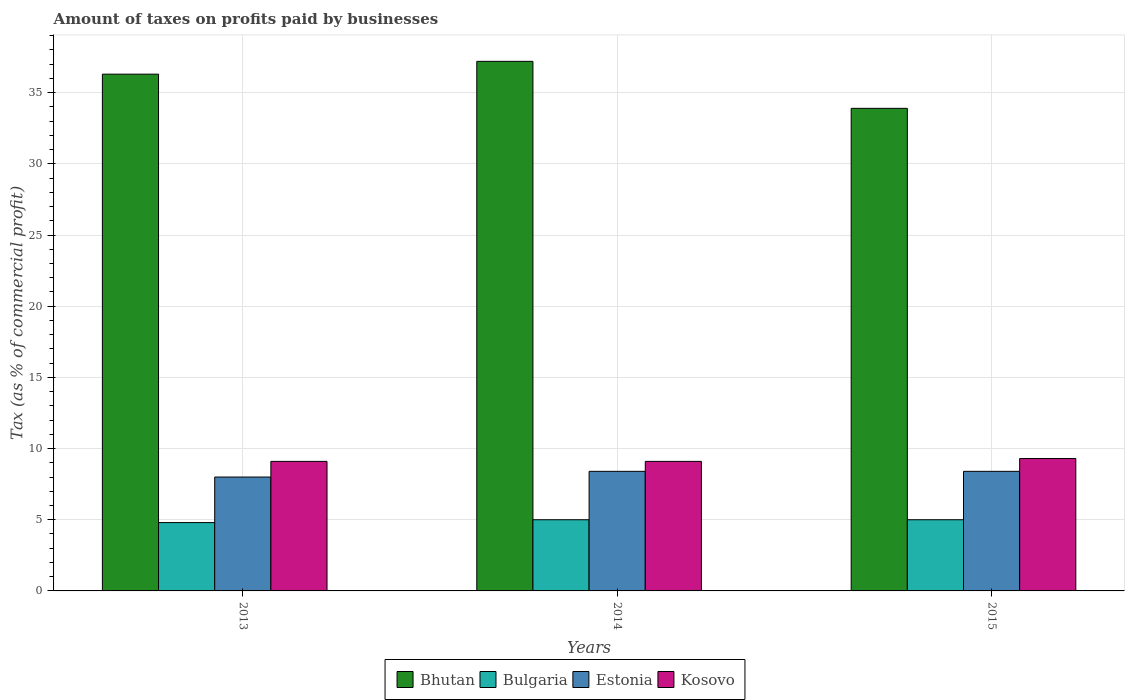How many different coloured bars are there?
Your answer should be very brief. 4. How many groups of bars are there?
Your answer should be compact. 3. Are the number of bars per tick equal to the number of legend labels?
Make the answer very short. Yes. Are the number of bars on each tick of the X-axis equal?
Provide a short and direct response. Yes. How many bars are there on the 1st tick from the left?
Offer a terse response. 4. In how many cases, is the number of bars for a given year not equal to the number of legend labels?
Your answer should be very brief. 0. Across all years, what is the maximum percentage of taxes paid by businesses in Estonia?
Offer a very short reply. 8.4. Across all years, what is the minimum percentage of taxes paid by businesses in Bulgaria?
Keep it short and to the point. 4.8. In which year was the percentage of taxes paid by businesses in Estonia minimum?
Offer a terse response. 2013. What is the total percentage of taxes paid by businesses in Estonia in the graph?
Offer a terse response. 24.8. What is the difference between the percentage of taxes paid by businesses in Bhutan in 2013 and that in 2015?
Make the answer very short. 2.4. What is the difference between the percentage of taxes paid by businesses in Estonia in 2015 and the percentage of taxes paid by businesses in Bhutan in 2013?
Provide a short and direct response. -27.9. What is the average percentage of taxes paid by businesses in Bhutan per year?
Make the answer very short. 35.8. In the year 2013, what is the difference between the percentage of taxes paid by businesses in Kosovo and percentage of taxes paid by businesses in Estonia?
Your answer should be compact. 1.1. In how many years, is the percentage of taxes paid by businesses in Bulgaria greater than 27 %?
Provide a short and direct response. 0. What is the ratio of the percentage of taxes paid by businesses in Bulgaria in 2014 to that in 2015?
Your answer should be compact. 1. Is the difference between the percentage of taxes paid by businesses in Kosovo in 2013 and 2014 greater than the difference between the percentage of taxes paid by businesses in Estonia in 2013 and 2014?
Make the answer very short. Yes. What is the difference between the highest and the lowest percentage of taxes paid by businesses in Bhutan?
Provide a succinct answer. 3.3. In how many years, is the percentage of taxes paid by businesses in Estonia greater than the average percentage of taxes paid by businesses in Estonia taken over all years?
Offer a very short reply. 2. What does the 3rd bar from the left in 2015 represents?
Your answer should be compact. Estonia. What does the 3rd bar from the right in 2013 represents?
Keep it short and to the point. Bulgaria. How many years are there in the graph?
Ensure brevity in your answer.  3. Are the values on the major ticks of Y-axis written in scientific E-notation?
Provide a succinct answer. No. Where does the legend appear in the graph?
Keep it short and to the point. Bottom center. How many legend labels are there?
Give a very brief answer. 4. What is the title of the graph?
Provide a succinct answer. Amount of taxes on profits paid by businesses. What is the label or title of the X-axis?
Make the answer very short. Years. What is the label or title of the Y-axis?
Provide a succinct answer. Tax (as % of commercial profit). What is the Tax (as % of commercial profit) in Bhutan in 2013?
Your answer should be compact. 36.3. What is the Tax (as % of commercial profit) of Bulgaria in 2013?
Offer a very short reply. 4.8. What is the Tax (as % of commercial profit) of Estonia in 2013?
Your answer should be compact. 8. What is the Tax (as % of commercial profit) of Kosovo in 2013?
Provide a succinct answer. 9.1. What is the Tax (as % of commercial profit) in Bhutan in 2014?
Give a very brief answer. 37.2. What is the Tax (as % of commercial profit) in Bulgaria in 2014?
Offer a very short reply. 5. What is the Tax (as % of commercial profit) of Estonia in 2014?
Provide a succinct answer. 8.4. What is the Tax (as % of commercial profit) of Bhutan in 2015?
Your answer should be very brief. 33.9. What is the Tax (as % of commercial profit) in Kosovo in 2015?
Your answer should be compact. 9.3. Across all years, what is the maximum Tax (as % of commercial profit) in Bhutan?
Ensure brevity in your answer.  37.2. Across all years, what is the maximum Tax (as % of commercial profit) in Bulgaria?
Offer a terse response. 5. Across all years, what is the maximum Tax (as % of commercial profit) of Kosovo?
Give a very brief answer. 9.3. Across all years, what is the minimum Tax (as % of commercial profit) in Bhutan?
Make the answer very short. 33.9. Across all years, what is the minimum Tax (as % of commercial profit) in Estonia?
Keep it short and to the point. 8. Across all years, what is the minimum Tax (as % of commercial profit) of Kosovo?
Provide a succinct answer. 9.1. What is the total Tax (as % of commercial profit) of Bhutan in the graph?
Ensure brevity in your answer.  107.4. What is the total Tax (as % of commercial profit) of Estonia in the graph?
Provide a short and direct response. 24.8. What is the difference between the Tax (as % of commercial profit) of Bulgaria in 2013 and that in 2014?
Your answer should be compact. -0.2. What is the difference between the Tax (as % of commercial profit) of Estonia in 2013 and that in 2014?
Keep it short and to the point. -0.4. What is the difference between the Tax (as % of commercial profit) of Kosovo in 2013 and that in 2014?
Provide a succinct answer. 0. What is the difference between the Tax (as % of commercial profit) in Estonia in 2013 and that in 2015?
Ensure brevity in your answer.  -0.4. What is the difference between the Tax (as % of commercial profit) in Estonia in 2014 and that in 2015?
Offer a terse response. 0. What is the difference between the Tax (as % of commercial profit) of Bhutan in 2013 and the Tax (as % of commercial profit) of Bulgaria in 2014?
Make the answer very short. 31.3. What is the difference between the Tax (as % of commercial profit) of Bhutan in 2013 and the Tax (as % of commercial profit) of Estonia in 2014?
Your answer should be compact. 27.9. What is the difference between the Tax (as % of commercial profit) of Bhutan in 2013 and the Tax (as % of commercial profit) of Kosovo in 2014?
Ensure brevity in your answer.  27.2. What is the difference between the Tax (as % of commercial profit) in Bulgaria in 2013 and the Tax (as % of commercial profit) in Kosovo in 2014?
Offer a terse response. -4.3. What is the difference between the Tax (as % of commercial profit) of Estonia in 2013 and the Tax (as % of commercial profit) of Kosovo in 2014?
Provide a succinct answer. -1.1. What is the difference between the Tax (as % of commercial profit) in Bhutan in 2013 and the Tax (as % of commercial profit) in Bulgaria in 2015?
Ensure brevity in your answer.  31.3. What is the difference between the Tax (as % of commercial profit) in Bhutan in 2013 and the Tax (as % of commercial profit) in Estonia in 2015?
Make the answer very short. 27.9. What is the difference between the Tax (as % of commercial profit) of Bulgaria in 2013 and the Tax (as % of commercial profit) of Kosovo in 2015?
Provide a succinct answer. -4.5. What is the difference between the Tax (as % of commercial profit) in Estonia in 2013 and the Tax (as % of commercial profit) in Kosovo in 2015?
Provide a short and direct response. -1.3. What is the difference between the Tax (as % of commercial profit) of Bhutan in 2014 and the Tax (as % of commercial profit) of Bulgaria in 2015?
Offer a terse response. 32.2. What is the difference between the Tax (as % of commercial profit) of Bhutan in 2014 and the Tax (as % of commercial profit) of Estonia in 2015?
Offer a very short reply. 28.8. What is the difference between the Tax (as % of commercial profit) of Bhutan in 2014 and the Tax (as % of commercial profit) of Kosovo in 2015?
Your answer should be compact. 27.9. What is the difference between the Tax (as % of commercial profit) in Bulgaria in 2014 and the Tax (as % of commercial profit) in Estonia in 2015?
Your response must be concise. -3.4. What is the difference between the Tax (as % of commercial profit) in Bulgaria in 2014 and the Tax (as % of commercial profit) in Kosovo in 2015?
Your answer should be compact. -4.3. What is the average Tax (as % of commercial profit) of Bhutan per year?
Provide a short and direct response. 35.8. What is the average Tax (as % of commercial profit) in Bulgaria per year?
Give a very brief answer. 4.93. What is the average Tax (as % of commercial profit) in Estonia per year?
Make the answer very short. 8.27. What is the average Tax (as % of commercial profit) in Kosovo per year?
Keep it short and to the point. 9.17. In the year 2013, what is the difference between the Tax (as % of commercial profit) of Bhutan and Tax (as % of commercial profit) of Bulgaria?
Your answer should be very brief. 31.5. In the year 2013, what is the difference between the Tax (as % of commercial profit) of Bhutan and Tax (as % of commercial profit) of Estonia?
Offer a terse response. 28.3. In the year 2013, what is the difference between the Tax (as % of commercial profit) of Bhutan and Tax (as % of commercial profit) of Kosovo?
Keep it short and to the point. 27.2. In the year 2013, what is the difference between the Tax (as % of commercial profit) of Bulgaria and Tax (as % of commercial profit) of Estonia?
Your answer should be compact. -3.2. In the year 2013, what is the difference between the Tax (as % of commercial profit) in Bulgaria and Tax (as % of commercial profit) in Kosovo?
Give a very brief answer. -4.3. In the year 2014, what is the difference between the Tax (as % of commercial profit) of Bhutan and Tax (as % of commercial profit) of Bulgaria?
Offer a very short reply. 32.2. In the year 2014, what is the difference between the Tax (as % of commercial profit) of Bhutan and Tax (as % of commercial profit) of Estonia?
Make the answer very short. 28.8. In the year 2014, what is the difference between the Tax (as % of commercial profit) of Bhutan and Tax (as % of commercial profit) of Kosovo?
Give a very brief answer. 28.1. In the year 2014, what is the difference between the Tax (as % of commercial profit) of Bulgaria and Tax (as % of commercial profit) of Estonia?
Offer a very short reply. -3.4. In the year 2014, what is the difference between the Tax (as % of commercial profit) of Estonia and Tax (as % of commercial profit) of Kosovo?
Your answer should be compact. -0.7. In the year 2015, what is the difference between the Tax (as % of commercial profit) in Bhutan and Tax (as % of commercial profit) in Bulgaria?
Provide a succinct answer. 28.9. In the year 2015, what is the difference between the Tax (as % of commercial profit) of Bhutan and Tax (as % of commercial profit) of Kosovo?
Your response must be concise. 24.6. In the year 2015, what is the difference between the Tax (as % of commercial profit) in Bulgaria and Tax (as % of commercial profit) in Estonia?
Make the answer very short. -3.4. In the year 2015, what is the difference between the Tax (as % of commercial profit) of Bulgaria and Tax (as % of commercial profit) of Kosovo?
Offer a terse response. -4.3. What is the ratio of the Tax (as % of commercial profit) of Bhutan in 2013 to that in 2014?
Ensure brevity in your answer.  0.98. What is the ratio of the Tax (as % of commercial profit) in Estonia in 2013 to that in 2014?
Provide a short and direct response. 0.95. What is the ratio of the Tax (as % of commercial profit) of Kosovo in 2013 to that in 2014?
Your answer should be very brief. 1. What is the ratio of the Tax (as % of commercial profit) in Bhutan in 2013 to that in 2015?
Make the answer very short. 1.07. What is the ratio of the Tax (as % of commercial profit) in Estonia in 2013 to that in 2015?
Your answer should be very brief. 0.95. What is the ratio of the Tax (as % of commercial profit) in Kosovo in 2013 to that in 2015?
Keep it short and to the point. 0.98. What is the ratio of the Tax (as % of commercial profit) in Bhutan in 2014 to that in 2015?
Your answer should be very brief. 1.1. What is the ratio of the Tax (as % of commercial profit) in Bulgaria in 2014 to that in 2015?
Give a very brief answer. 1. What is the ratio of the Tax (as % of commercial profit) in Estonia in 2014 to that in 2015?
Ensure brevity in your answer.  1. What is the ratio of the Tax (as % of commercial profit) in Kosovo in 2014 to that in 2015?
Give a very brief answer. 0.98. What is the difference between the highest and the second highest Tax (as % of commercial profit) of Bhutan?
Make the answer very short. 0.9. What is the difference between the highest and the second highest Tax (as % of commercial profit) in Bulgaria?
Keep it short and to the point. 0. What is the difference between the highest and the second highest Tax (as % of commercial profit) in Estonia?
Your response must be concise. 0. What is the difference between the highest and the second highest Tax (as % of commercial profit) of Kosovo?
Keep it short and to the point. 0.2. What is the difference between the highest and the lowest Tax (as % of commercial profit) of Bhutan?
Keep it short and to the point. 3.3. What is the difference between the highest and the lowest Tax (as % of commercial profit) in Estonia?
Ensure brevity in your answer.  0.4. 